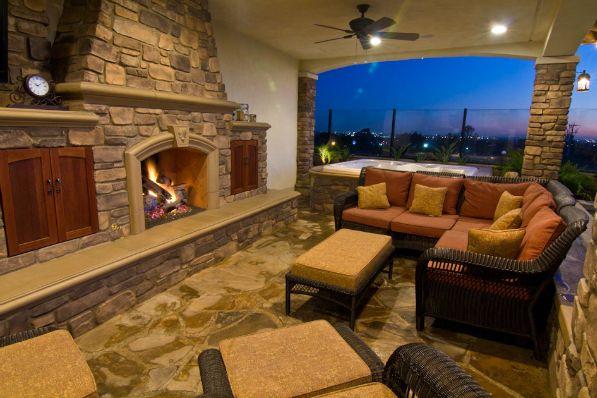How many people are in the room?
Concise answer only. 0. What time of day was this photo taken?
Short answer required. Night. How many pillows do you see?
Answer briefly. 5. 